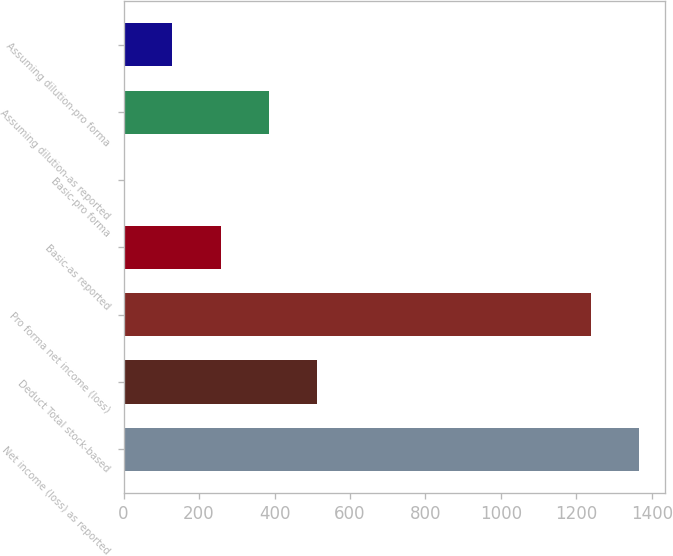Convert chart. <chart><loc_0><loc_0><loc_500><loc_500><bar_chart><fcel>Net income (loss) as reported<fcel>Deduct Total stock-based<fcel>Pro forma net income (loss)<fcel>Basic-as reported<fcel>Basic-pro forma<fcel>Assuming dilution-as reported<fcel>Assuming dilution-pro forma<nl><fcel>1366.96<fcel>513.28<fcel>1239<fcel>257.36<fcel>1.44<fcel>385.32<fcel>129.4<nl></chart> 